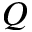Convert formula to latex. <formula><loc_0><loc_0><loc_500><loc_500>Q</formula> 